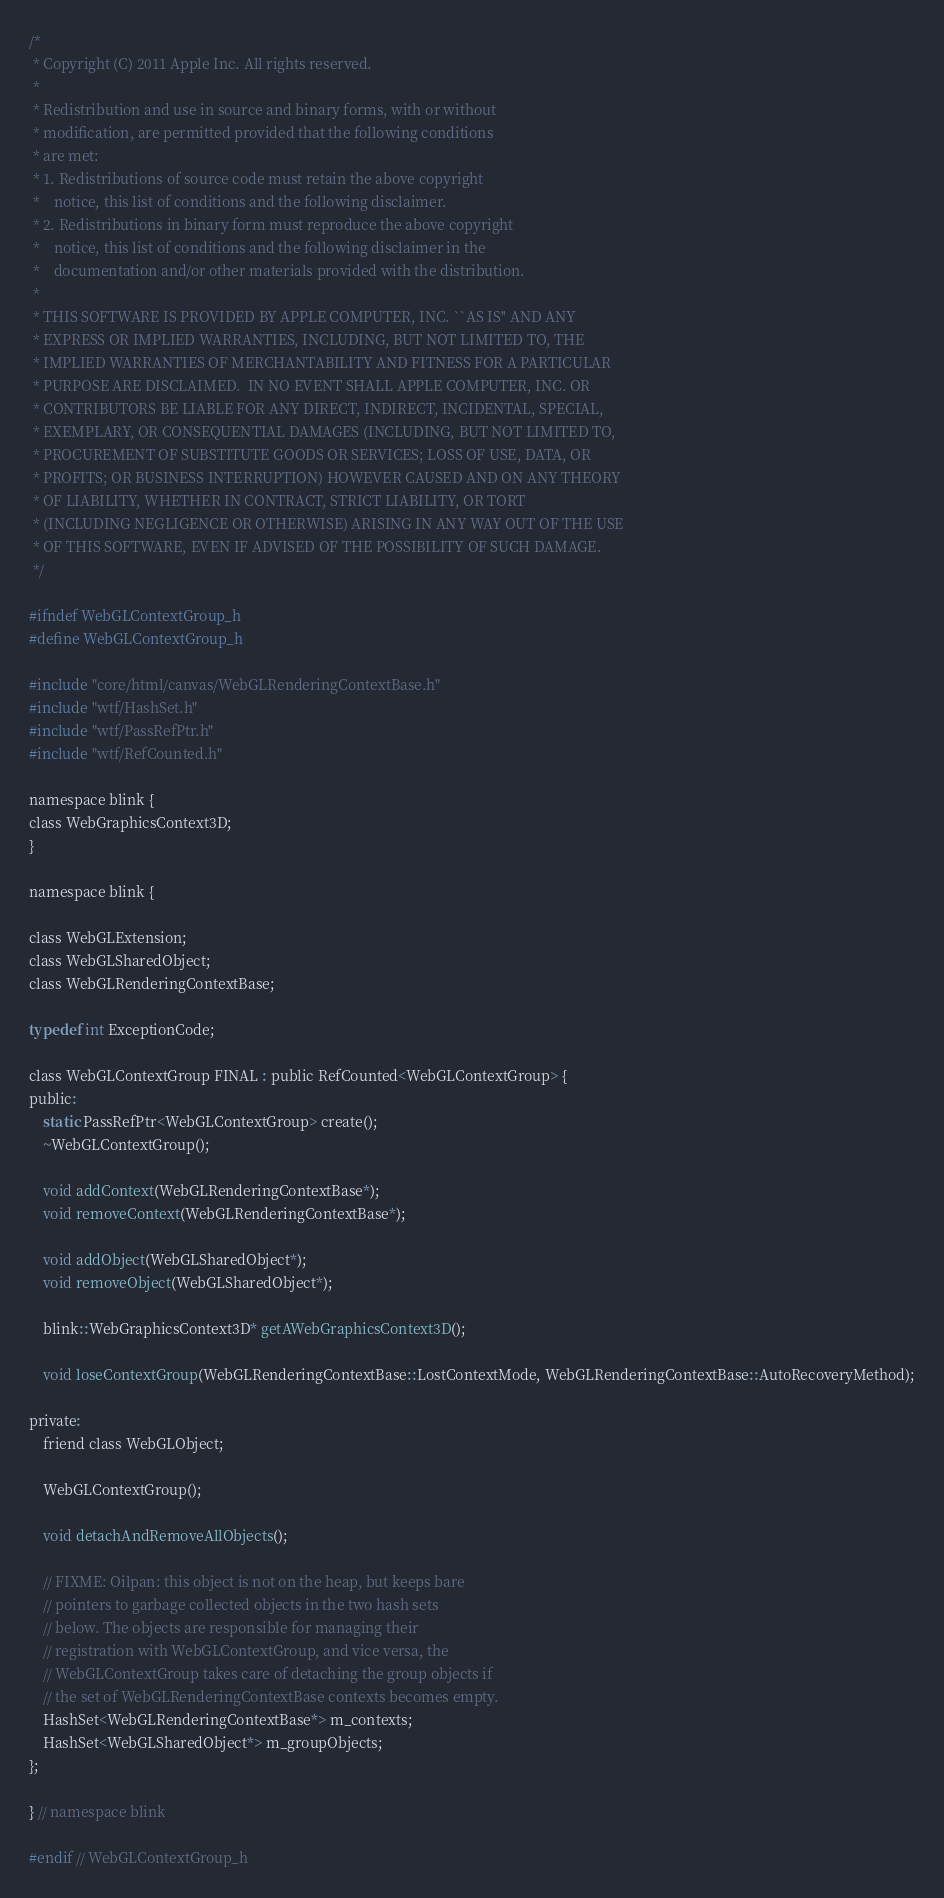<code> <loc_0><loc_0><loc_500><loc_500><_C_>/*
 * Copyright (C) 2011 Apple Inc. All rights reserved.
 *
 * Redistribution and use in source and binary forms, with or without
 * modification, are permitted provided that the following conditions
 * are met:
 * 1. Redistributions of source code must retain the above copyright
 *    notice, this list of conditions and the following disclaimer.
 * 2. Redistributions in binary form must reproduce the above copyright
 *    notice, this list of conditions and the following disclaimer in the
 *    documentation and/or other materials provided with the distribution.
 *
 * THIS SOFTWARE IS PROVIDED BY APPLE COMPUTER, INC. ``AS IS'' AND ANY
 * EXPRESS OR IMPLIED WARRANTIES, INCLUDING, BUT NOT LIMITED TO, THE
 * IMPLIED WARRANTIES OF MERCHANTABILITY AND FITNESS FOR A PARTICULAR
 * PURPOSE ARE DISCLAIMED.  IN NO EVENT SHALL APPLE COMPUTER, INC. OR
 * CONTRIBUTORS BE LIABLE FOR ANY DIRECT, INDIRECT, INCIDENTAL, SPECIAL,
 * EXEMPLARY, OR CONSEQUENTIAL DAMAGES (INCLUDING, BUT NOT LIMITED TO,
 * PROCUREMENT OF SUBSTITUTE GOODS OR SERVICES; LOSS OF USE, DATA, OR
 * PROFITS; OR BUSINESS INTERRUPTION) HOWEVER CAUSED AND ON ANY THEORY
 * OF LIABILITY, WHETHER IN CONTRACT, STRICT LIABILITY, OR TORT
 * (INCLUDING NEGLIGENCE OR OTHERWISE) ARISING IN ANY WAY OUT OF THE USE
 * OF THIS SOFTWARE, EVEN IF ADVISED OF THE POSSIBILITY OF SUCH DAMAGE.
 */

#ifndef WebGLContextGroup_h
#define WebGLContextGroup_h

#include "core/html/canvas/WebGLRenderingContextBase.h"
#include "wtf/HashSet.h"
#include "wtf/PassRefPtr.h"
#include "wtf/RefCounted.h"

namespace blink {
class WebGraphicsContext3D;
}

namespace blink {

class WebGLExtension;
class WebGLSharedObject;
class WebGLRenderingContextBase;

typedef int ExceptionCode;

class WebGLContextGroup FINAL : public RefCounted<WebGLContextGroup> {
public:
    static PassRefPtr<WebGLContextGroup> create();
    ~WebGLContextGroup();

    void addContext(WebGLRenderingContextBase*);
    void removeContext(WebGLRenderingContextBase*);

    void addObject(WebGLSharedObject*);
    void removeObject(WebGLSharedObject*);

    blink::WebGraphicsContext3D* getAWebGraphicsContext3D();

    void loseContextGroup(WebGLRenderingContextBase::LostContextMode, WebGLRenderingContextBase::AutoRecoveryMethod);

private:
    friend class WebGLObject;

    WebGLContextGroup();

    void detachAndRemoveAllObjects();

    // FIXME: Oilpan: this object is not on the heap, but keeps bare
    // pointers to garbage collected objects in the two hash sets
    // below. The objects are responsible for managing their
    // registration with WebGLContextGroup, and vice versa, the
    // WebGLContextGroup takes care of detaching the group objects if
    // the set of WebGLRenderingContextBase contexts becomes empty.
    HashSet<WebGLRenderingContextBase*> m_contexts;
    HashSet<WebGLSharedObject*> m_groupObjects;
};

} // namespace blink

#endif // WebGLContextGroup_h
</code> 